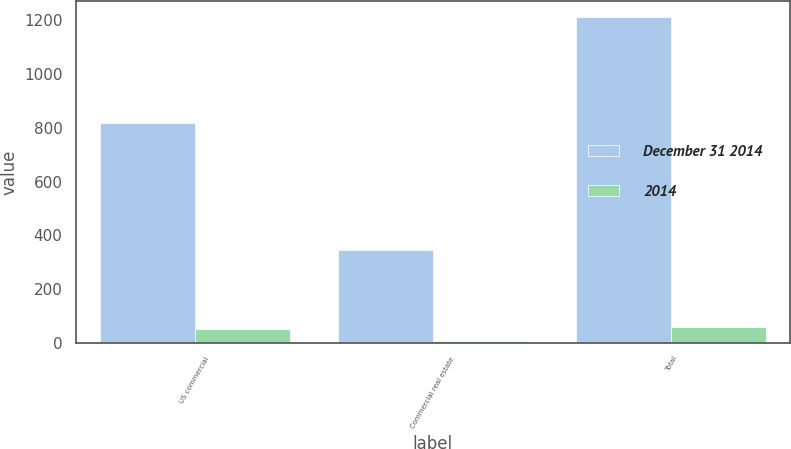Convert chart to OTSL. <chart><loc_0><loc_0><loc_500><loc_500><stacked_bar_chart><ecel><fcel>US commercial<fcel>Commercial real estate<fcel>Total<nl><fcel>December 31 2014<fcel>818<fcel>346<fcel>1211<nl><fcel>2014<fcel>49<fcel>8<fcel>57<nl></chart> 